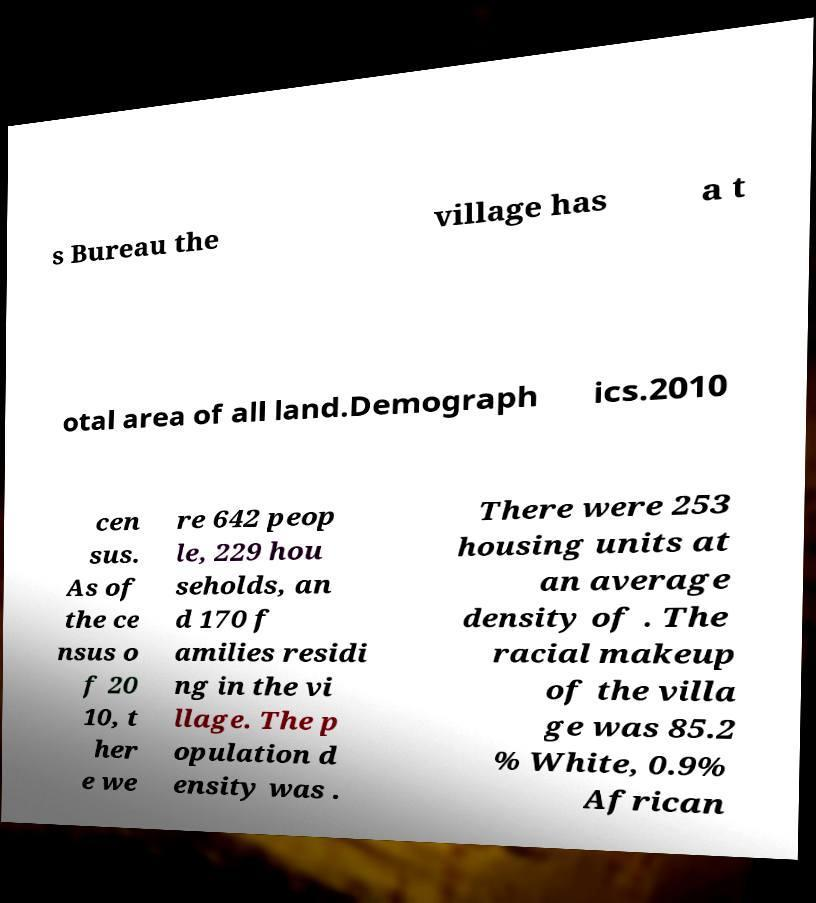Could you extract and type out the text from this image? s Bureau the village has a t otal area of all land.Demograph ics.2010 cen sus. As of the ce nsus o f 20 10, t her e we re 642 peop le, 229 hou seholds, an d 170 f amilies residi ng in the vi llage. The p opulation d ensity was . There were 253 housing units at an average density of . The racial makeup of the villa ge was 85.2 % White, 0.9% African 